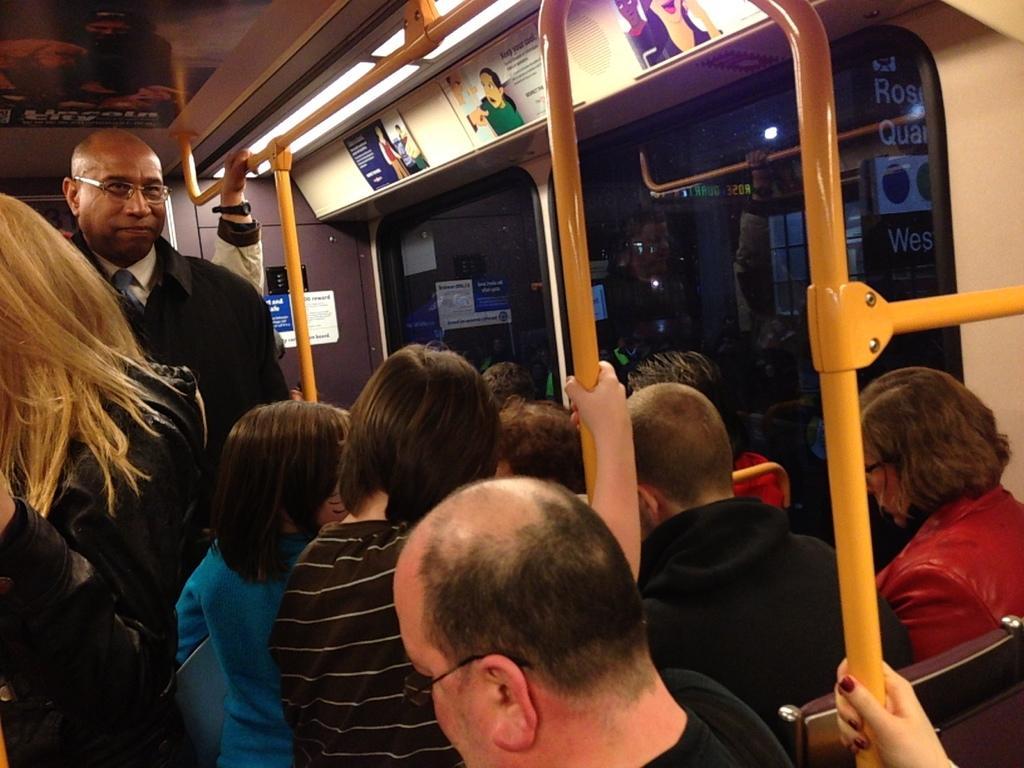Describe this image in one or two sentences. In this image I can see the group of people with different color dresses. I can see these people are in the vehicle. In the background I can see the boards and the glass windows. I can see the metal rods. 